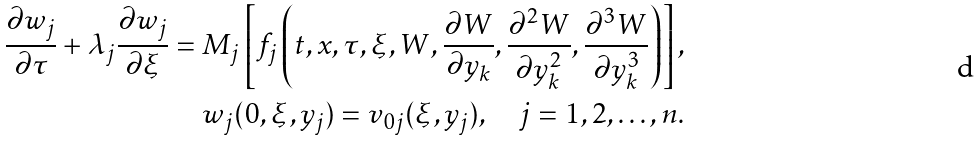<formula> <loc_0><loc_0><loc_500><loc_500>\frac { \partial w _ { j } } { \partial \tau } + \lambda _ { j } \frac { \partial w _ { j } } { \partial \xi } = M _ { j } \left [ f _ { j } \left ( t , x , \tau , \xi , W , \frac { \partial W } { \partial y _ { k } } , \frac { \partial ^ { 2 } W } { \partial y _ { k } ^ { 2 } } , \frac { \partial ^ { 3 } W } { \partial y _ { k } ^ { 3 } } \right ) \right ] , \\ w _ { j } ( 0 , \xi , y _ { j } ) = v _ { 0 j } ( \xi , y _ { j } ) , \quad j = 1 , 2 , \dots , n .</formula> 